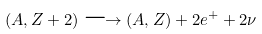<formula> <loc_0><loc_0><loc_500><loc_500>( A , Z + 2 ) \longrightarrow ( A , Z ) + 2 e ^ { + } + 2 \nu</formula> 